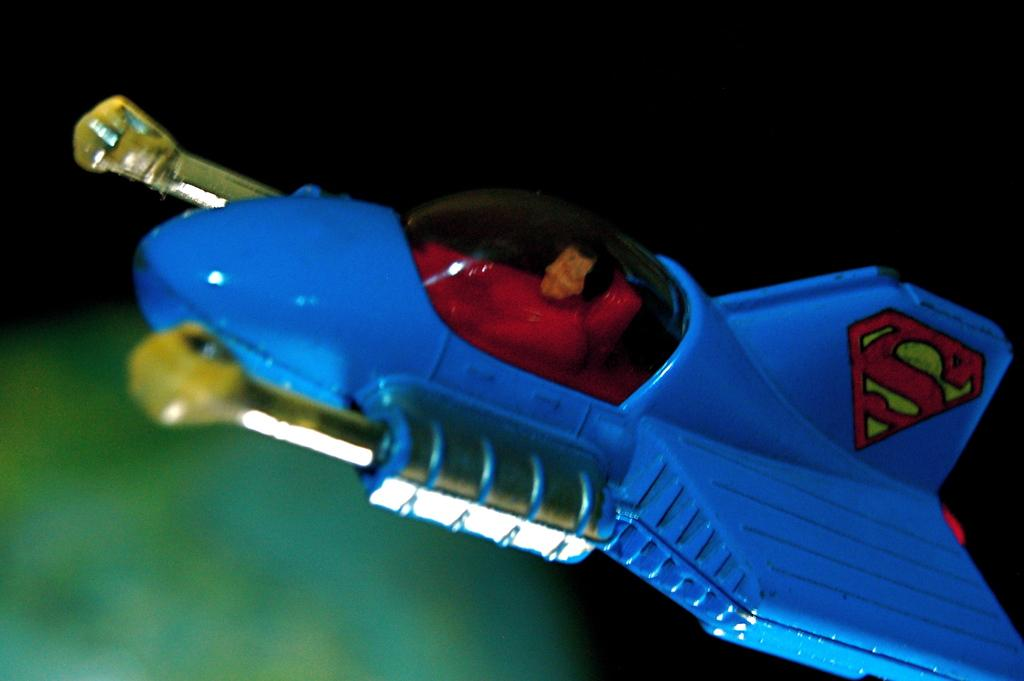<image>
Provide a brief description of the given image. An S on a bright blue toy plane with a figurine sitting at the wheel. 